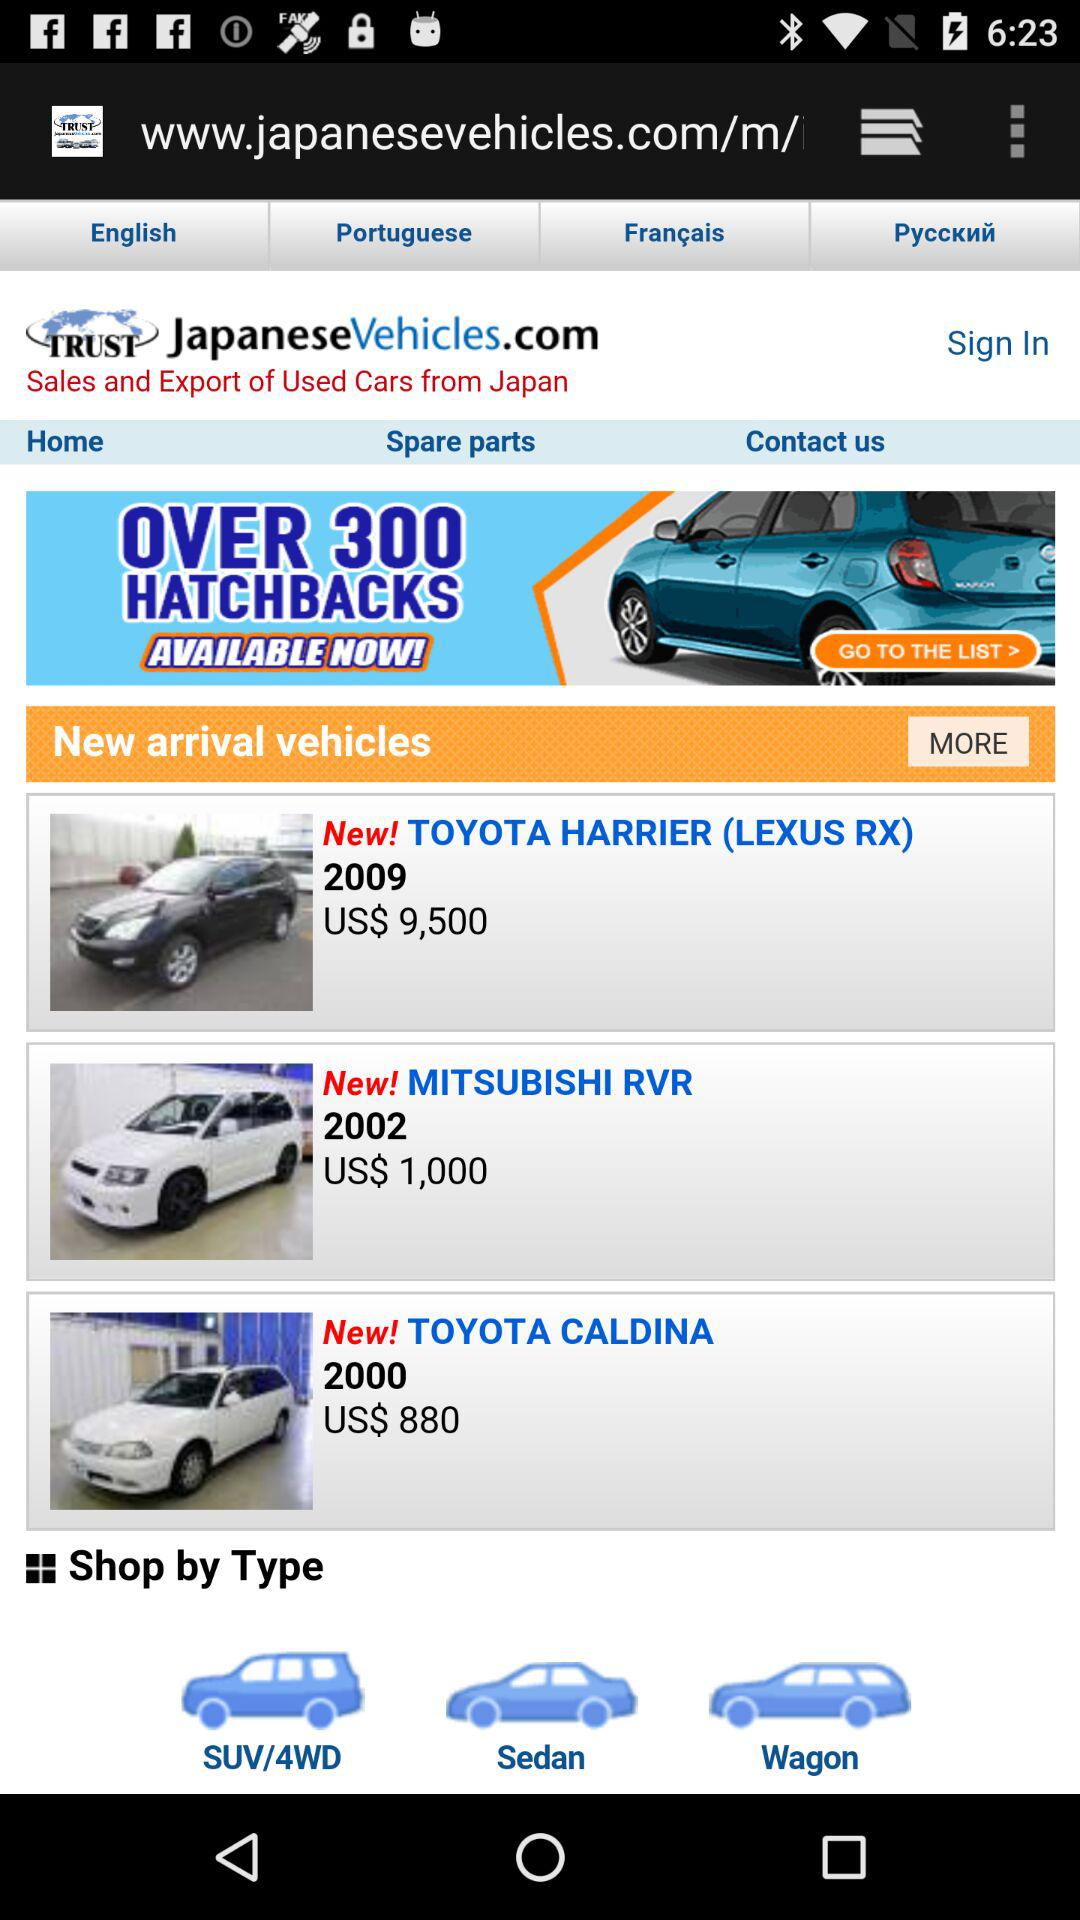Which are the type of cars available? The types of cars available are "SUV/4WD", "Sedan", and "Wagon". 